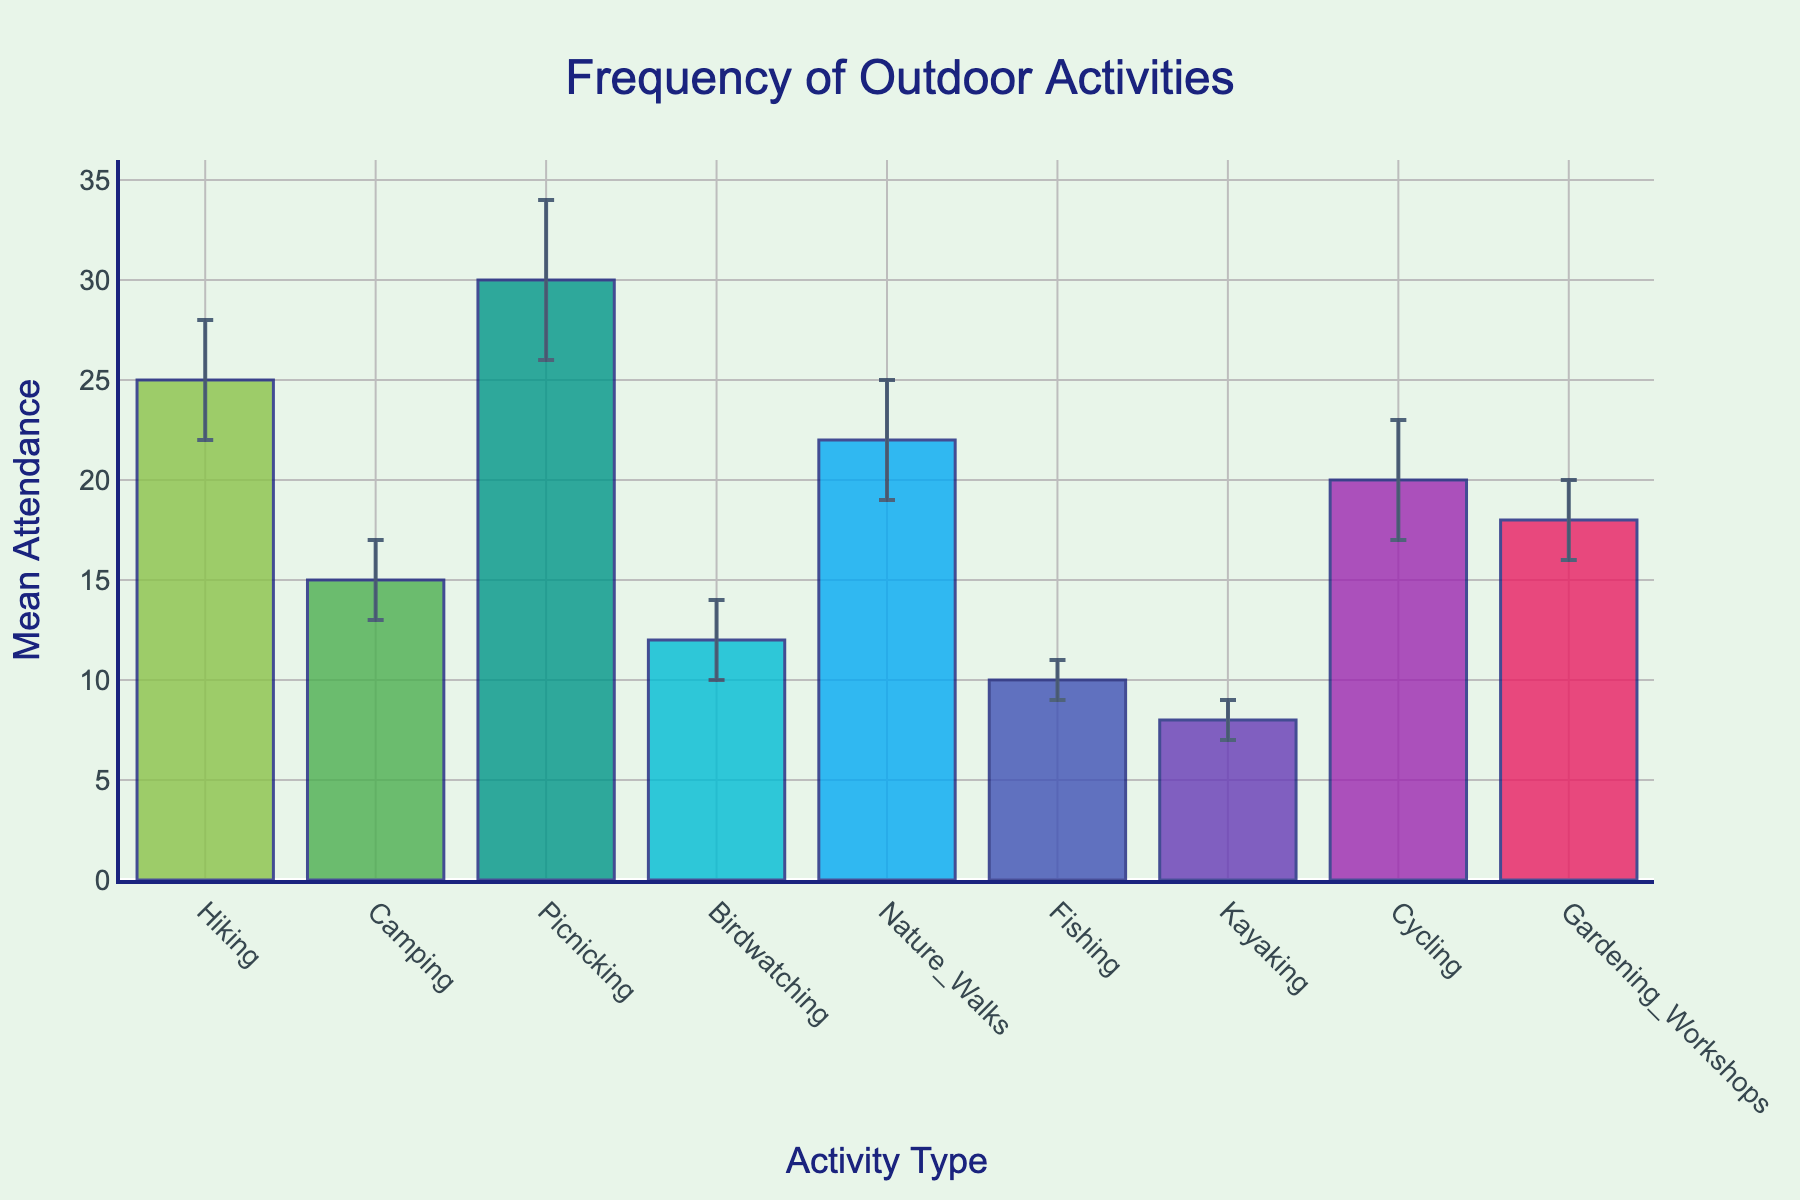What is the title of the bar chart? The title is visible at the top of the chart.
Answer: "Frequency of Outdoor Activities" What activity has the highest mean attendance? By looking at the height of the bars, Picnicking has the highest value.
Answer: Picnicking Which activity has the smallest error margin? The error margin is represented by the error bars. Fishing and Kayaking both have the smallest error bars.
Answer: Fishing or Kayaking What is the mean attendance of Camping? Locate the Camping bar and refer to its height on the y-axis.
Answer: 15 Which two activities have a mean attendance difference of 10? Look for bars whose height difference on the y-axis is 10. Hiking (25) and Camping (15), and Gardening Workshops (18) and Birdwatching (12).
Answer: Hiking and Camping or Gardening Workshops and Birdwatching How does the mean attendance of Nature Walks compare to that of Cycling? Compare the heights of Nature Walks (22) and Cycling (20) bars. Nature Walks is slightly higher.
Answer: Nature Walks is greater Calculate the average mean attendance of all the activities. Sum all the mean attendance values and divide by the number of activities: (25+15+30+12+22+10+8+20+18) / 9 = 160 / 9 ≈ 17.78.
Answer: 17.78 If the error margin is considered, what is the minimum and maximum attendance for Birdwatching? For Birdwatching, the mean is 12 with an error margin of 2, so minimum is 12-2=10 and maximum is 12+2=14.
Answer: Minimum 10, Maximum 14 Which activity shows the most variability in attendance? Find the bar with the largest error margin. Picnicking has the largest error bar of 4.
Answer: Picnicking How many activities have a mean attendance greater than 20? Count the bars whose heights on the y-axis are greater than 20. There are four: Hiking, Picnicking, Nature Walks, and Cycling.
Answer: 4 